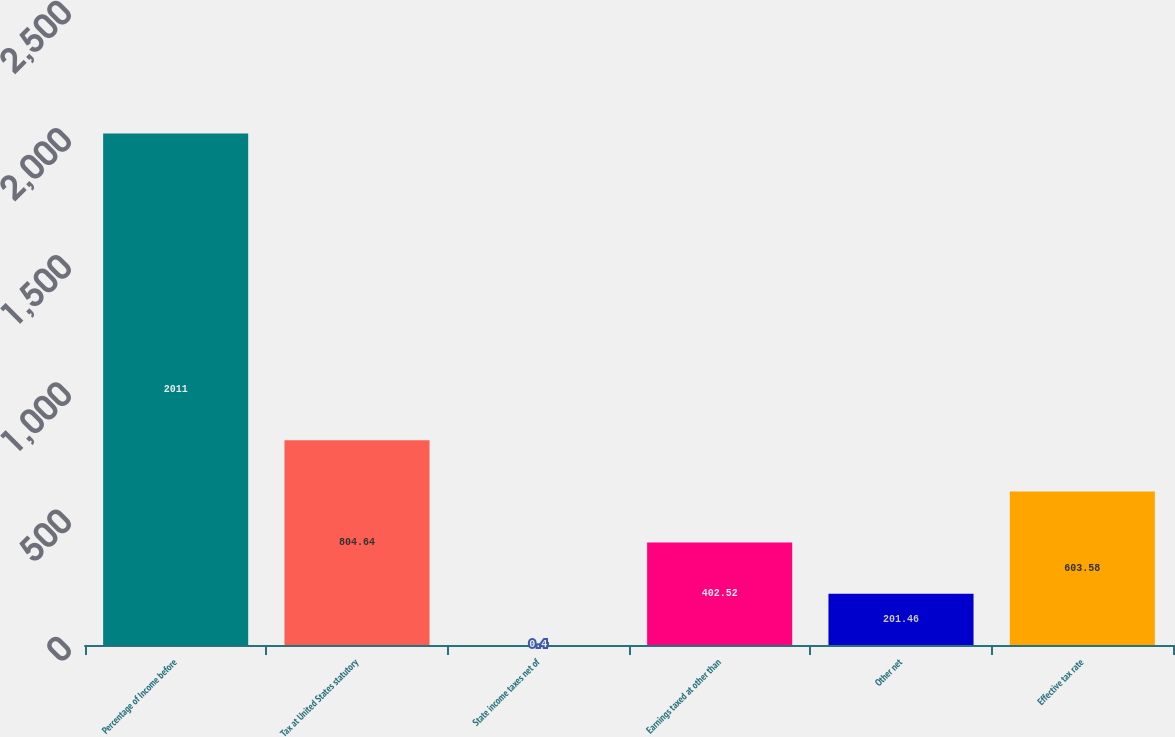<chart> <loc_0><loc_0><loc_500><loc_500><bar_chart><fcel>Percentage of Income before<fcel>Tax at United States statutory<fcel>State income taxes net of<fcel>Earnings taxed at other than<fcel>Other net<fcel>Effective tax rate<nl><fcel>2011<fcel>804.64<fcel>0.4<fcel>402.52<fcel>201.46<fcel>603.58<nl></chart> 